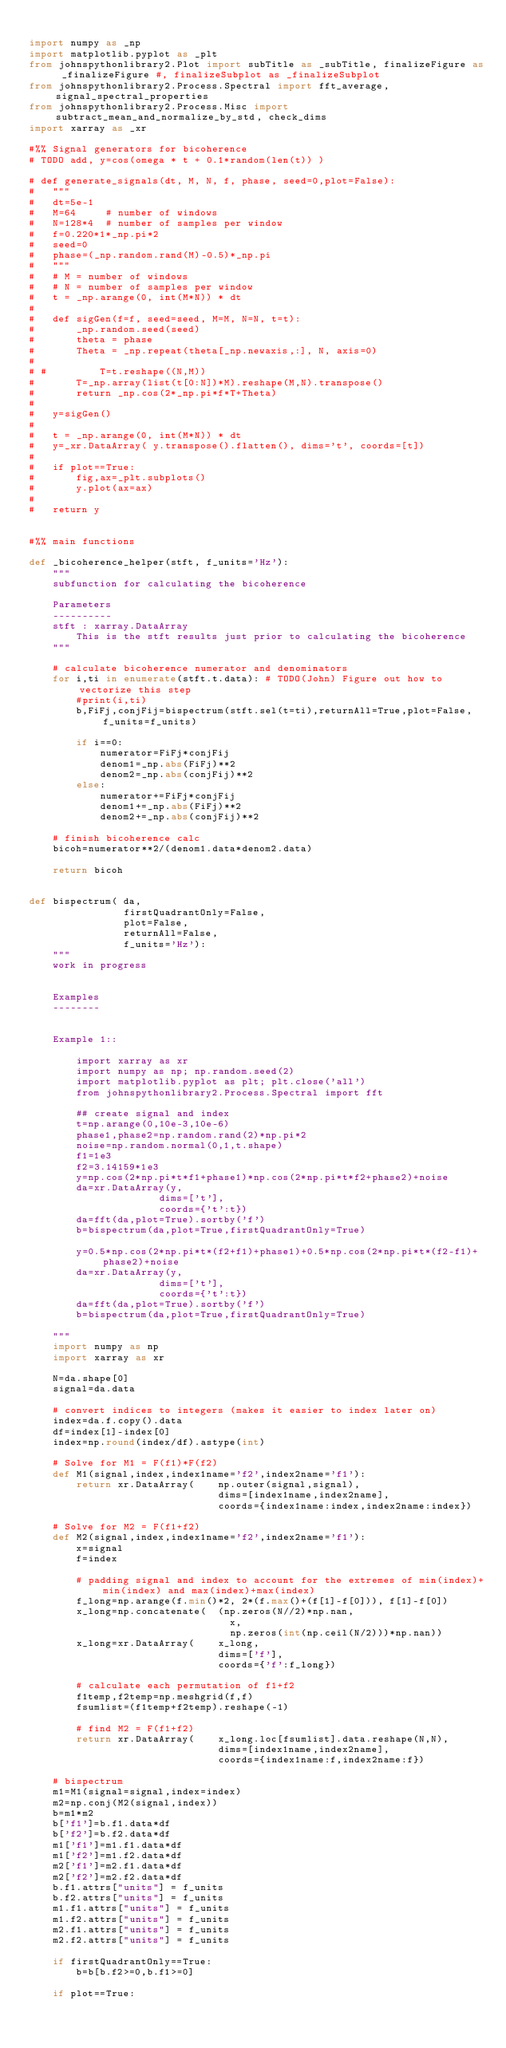Convert code to text. <code><loc_0><loc_0><loc_500><loc_500><_Python_>
import numpy as _np
import matplotlib.pyplot as _plt
from johnspythonlibrary2.Plot import subTitle as _subTitle, finalizeFigure as _finalizeFigure #, finalizeSubplot as _finalizeSubplot
from johnspythonlibrary2.Process.Spectral import fft_average, signal_spectral_properties
from johnspythonlibrary2.Process.Misc import subtract_mean_and_normalize_by_std, check_dims
import xarray as _xr

#%% Signal generators for bicoherence
# TODO add, y=cos(omega * t + 0.1*random(len(t)) )

# def generate_signals(dt, M, N, f, phase, seed=0,plot=False):
# 	"""
# 	dt=5e-1
# 	M=64     # number of windows
# 	N=128*4  # number of samples per window
# 	f=0.220*1*_np.pi*2
# 	seed=0
# 	phase=(_np.random.rand(M)-0.5)*_np.pi
# 	"""
# 	# M = number of windows
# 	# N = number of samples per window
# 	t = _np.arange(0, int(M*N)) * dt
# 	
# 	def sigGen(f=f, seed=seed, M=M, N=N, t=t):
# 		_np.random.seed(seed)
# 		theta = phase
# 		Theta = _np.repeat(theta[_np.newaxis,:], N, axis=0)
# 		
# # 		T=t.reshape((N,M))
# 		T=_np.array(list(t[0:N])*M).reshape(M,N).transpose()
# 		return _np.cos(2*_np.pi*f*T+Theta)
# 	
# 	y=sigGen()
# 	
# 	t = _np.arange(0, int(M*N)) * dt
# 	y=_xr.DataArray( y.transpose().flatten(), dims='t', coords=[t])
# 	
# 	if plot==True:
# 		fig,ax=_plt.subplots()
# 		y.plot(ax=ax)
# 	
# 	return y


#%% main functions

def _bicoherence_helper(stft, f_units='Hz'):
	""" 
	subfunction for calculating the bicoherence 
	
	Parameters
	----------
	stft : xarray.DataArray
		This is the stft results just prior to calculating the bicoherence
	"""

	# calculate bicoherence numerator and denominators
	for i,ti in enumerate(stft.t.data): # TODO(John) Figure out how to vectorize this step
		#print(i,ti)
		b,FiFj,conjFij=bispectrum(stft.sel(t=ti),returnAll=True,plot=False,f_units=f_units)
		
		if i==0:
			numerator=FiFj*conjFij
			denom1=_np.abs(FiFj)**2
			denom2=_np.abs(conjFij)**2
		else:
			numerator+=FiFj*conjFij
			denom1+=_np.abs(FiFj)**2
			denom2+=_np.abs(conjFij)**2
			
	# finish bicoherence calc
	bicoh=numerator**2/(denom1.data*denom2.data)
	
	return bicoh


def bispectrum(	da,
				firstQuadrantOnly=False,
				plot=False,
				returnAll=False,
				f_units='Hz'):
	"""
	work in progress
	
	
	Examples
	--------
		
		
	Example 1::
		
		import xarray as xr
		import numpy as np; np.random.seed(2)
		import matplotlib.pyplot as plt; plt.close('all')
		from johnspythonlibrary2.Process.Spectral import fft
		
		## create signal and index
		t=np.arange(0,10e-3,10e-6)
		phase1,phase2=np.random.rand(2)*np.pi*2
		noise=np.random.normal(0,1,t.shape)
		f1=1e3
		f2=3.14159*1e3
		y=np.cos(2*np.pi*t*f1+phase1)*np.cos(2*np.pi*t*f2+phase2)+noise
		da=xr.DataArray(y,
					  dims=['t'],
					  coords={'t':t})
		da=fft(da,plot=True).sortby('f')
		b=bispectrum(da,plot=True,firstQuadrantOnly=True)
		
		y=0.5*np.cos(2*np.pi*t*(f2+f1)+phase1)+0.5*np.cos(2*np.pi*t*(f2-f1)+phase2)+noise
		da=xr.DataArray(y,
					  dims=['t'],
					  coords={'t':t})
		da=fft(da,plot=True).sortby('f')
		b=bispectrum(da,plot=True,firstQuadrantOnly=True)
		
	"""
	import numpy as np
	import xarray as xr
	
	N=da.shape[0]
	signal=da.data

	# convert indices to integers (makes it easier to index later on)
	index=da.f.copy().data
	df=index[1]-index[0]
	index=np.round(index/df).astype(int)
	
	# Solve for M1 = F(f1)*F(f2)
	def M1(signal,index,index1name='f2',index2name='f1'):
		return xr.DataArray(	np.outer(signal,signal),
				 			    dims=[index1name,index2name],
								coords={index1name:index,index2name:index})
	
	# Solve for M2 = F(f1+f2)
	def M2(signal,index,index1name='f2',index2name='f1'):
		x=signal
		f=index
		
		# padding signal and index to account for the extremes of min(index)+min(index) and max(index)+max(index)
		f_long=np.arange(f.min()*2, 2*(f.max()+(f[1]-f[0])), f[1]-f[0])
		x_long=np.concatenate(	(np.zeros(N//2)*np.nan,
								  x,
								  np.zeros(int(np.ceil(N/2)))*np.nan))
		x_long=xr.DataArray(	x_long,
				 			    dims=['f'],
								coords={'f':f_long})
		
		# calculate each permutation of f1+f2
		f1temp,f2temp=np.meshgrid(f,f)
		fsumlist=(f1temp+f2temp).reshape(-1)
		
		# find M2 = F(f1+f2)
		return xr.DataArray(	x_long.loc[fsumlist].data.reshape(N,N),
				 			    dims=[index1name,index2name],
								coords={index1name:f,index2name:f})
	
	# bispectrum
	m1=M1(signal=signal,index=index)
	m2=np.conj(M2(signal,index))
	b=m1*m2
	b['f1']=b.f1.data*df
	b['f2']=b.f2.data*df
	m1['f1']=m1.f1.data*df
	m1['f2']=m1.f2.data*df
	m2['f1']=m2.f1.data*df
	m2['f2']=m2.f2.data*df
	b.f1.attrs["units"] = f_units
	b.f2.attrs["units"] = f_units
	m1.f1.attrs["units"] = f_units
	m1.f2.attrs["units"] = f_units
	m2.f1.attrs["units"] = f_units
	m2.f2.attrs["units"] = f_units
	
	if firstQuadrantOnly==True:
		b=b[b.f2>=0,b.f1>=0]
	
	if plot==True:</code> 